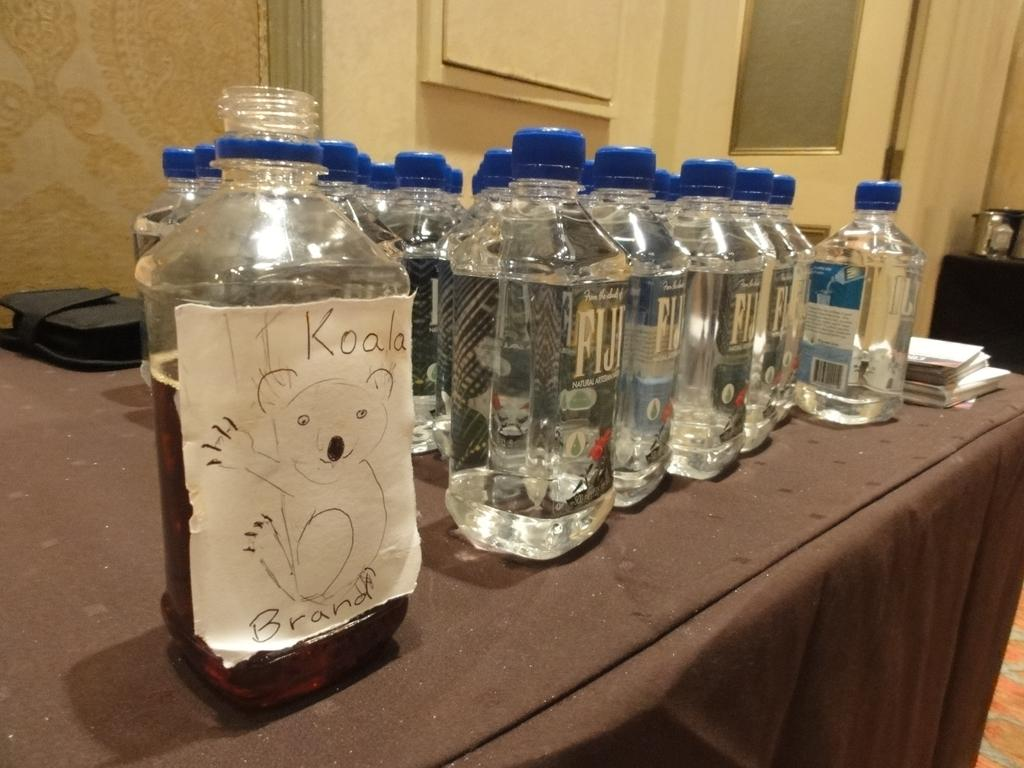<image>
Describe the image concisely. A table with bottles of Fiji water on it and then a bottle with a handwritten label saying Koala brand. 